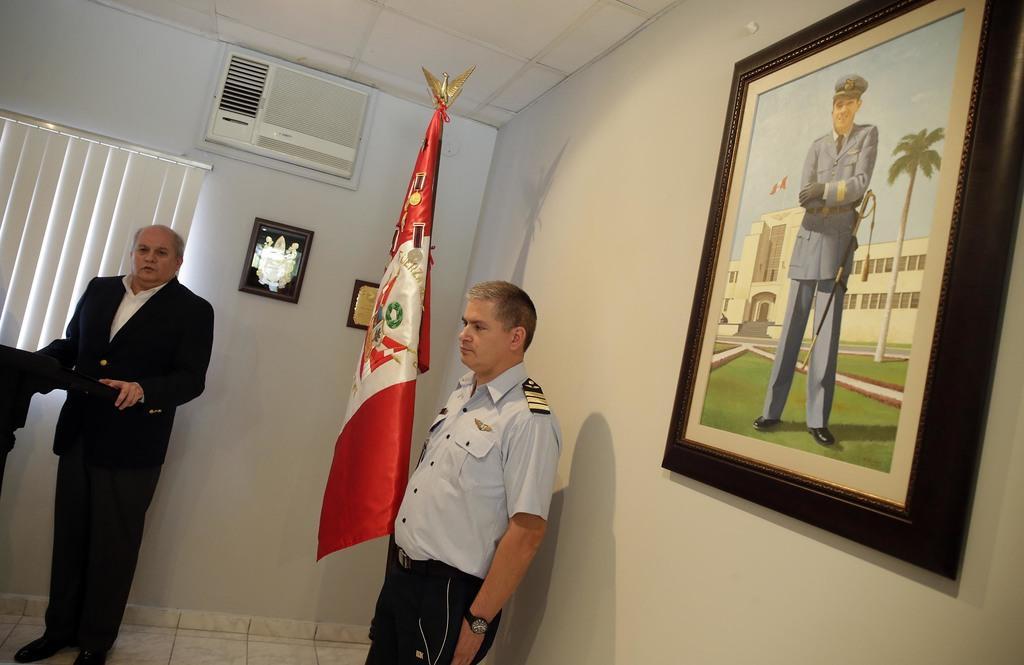In one or two sentences, can you explain what this image depicts? In this image I can see two people standing inside the house. These people are wearing the different color dresses. To the side of these people I can see the flag. I can see the borders and frames to the wall. I can see the window blind and the air-conditioner. 